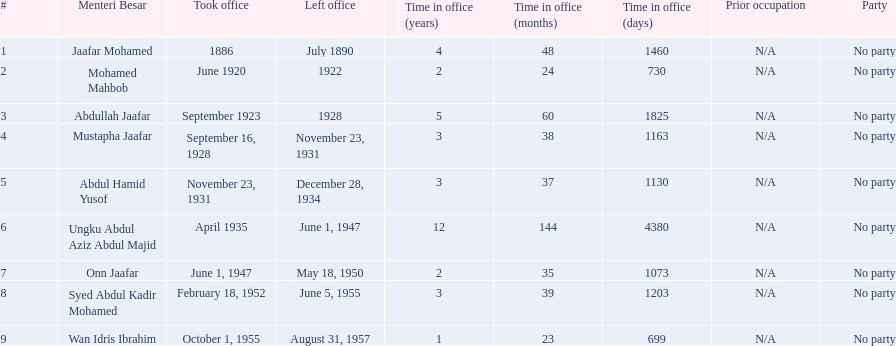When did jaafar mohamed take office? 1886. When did mohamed mahbob take office? June 1920. Who was in office no more than 4 years? Mohamed Mahbob. 